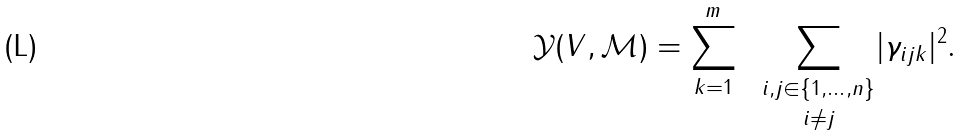<formula> <loc_0><loc_0><loc_500><loc_500>\mathcal { Y } ( V , \mathcal { M } ) = \sum ^ { m } _ { k = 1 } \ \ { \underset { i \not = j } { \underset { i , j \in \{ 1 , \dots , n \} } \sum } } | \gamma _ { i j k } | ^ { 2 } .</formula> 